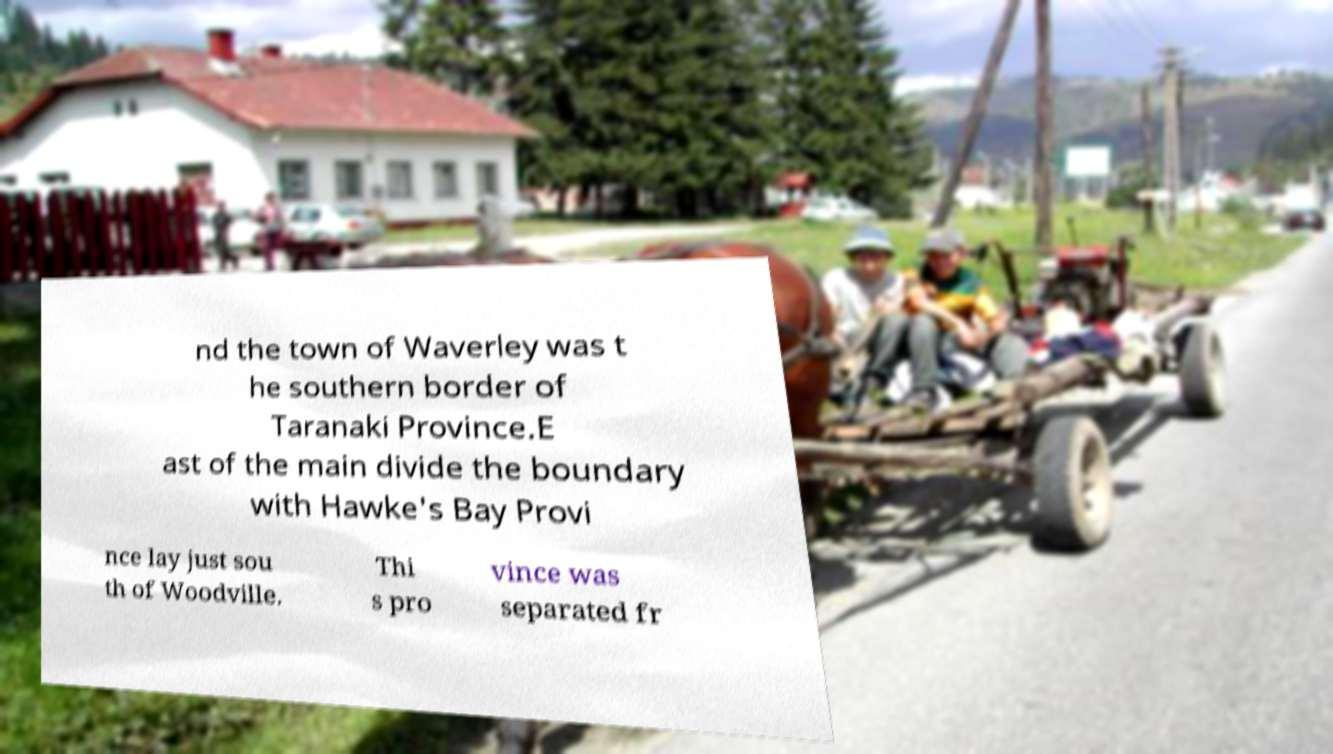Please read and relay the text visible in this image. What does it say? nd the town of Waverley was t he southern border of Taranaki Province.E ast of the main divide the boundary with Hawke's Bay Provi nce lay just sou th of Woodville. Thi s pro vince was separated fr 